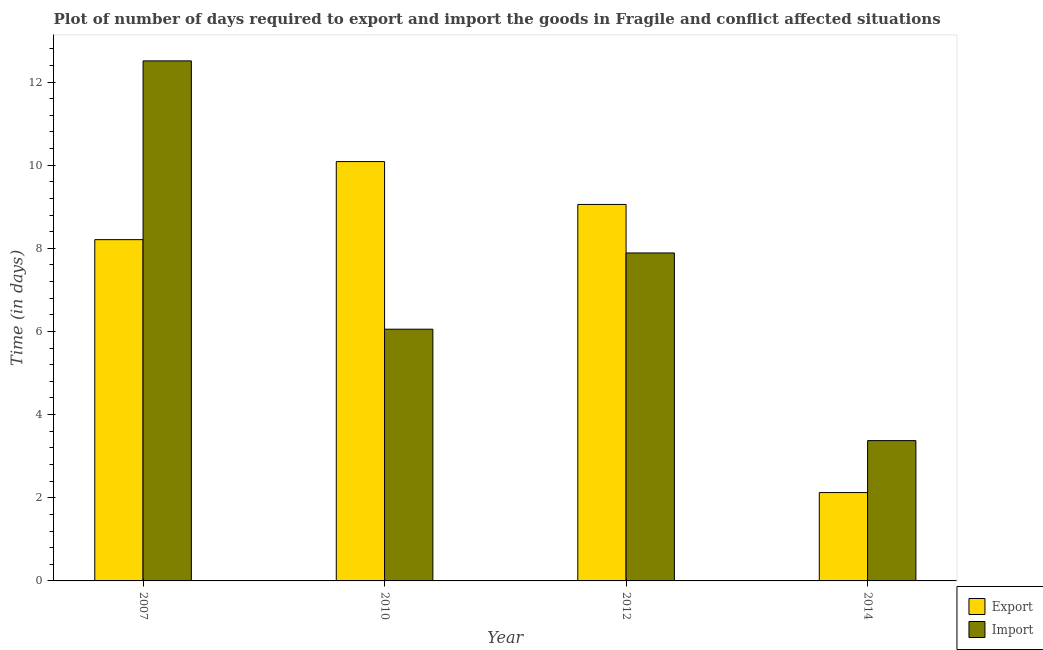Are the number of bars per tick equal to the number of legend labels?
Offer a very short reply. Yes. Are the number of bars on each tick of the X-axis equal?
Keep it short and to the point. Yes. How many bars are there on the 1st tick from the left?
Ensure brevity in your answer.  2. In how many cases, is the number of bars for a given year not equal to the number of legend labels?
Your response must be concise. 0. What is the time required to import in 2010?
Your answer should be very brief. 6.05. Across all years, what is the maximum time required to import?
Your answer should be compact. 12.51. Across all years, what is the minimum time required to import?
Your answer should be very brief. 3.38. What is the total time required to export in the graph?
Give a very brief answer. 29.48. What is the difference between the time required to export in 2007 and that in 2014?
Make the answer very short. 6.08. What is the difference between the time required to export in 2012 and the time required to import in 2010?
Ensure brevity in your answer.  -1.03. What is the average time required to import per year?
Make the answer very short. 7.46. In the year 2007, what is the difference between the time required to export and time required to import?
Keep it short and to the point. 0. What is the ratio of the time required to export in 2007 to that in 2014?
Give a very brief answer. 3.86. What is the difference between the highest and the second highest time required to export?
Your answer should be compact. 1.03. What is the difference between the highest and the lowest time required to export?
Your answer should be compact. 7.96. What does the 1st bar from the left in 2012 represents?
Make the answer very short. Export. What does the 2nd bar from the right in 2012 represents?
Your response must be concise. Export. Are all the bars in the graph horizontal?
Keep it short and to the point. No. What is the difference between two consecutive major ticks on the Y-axis?
Keep it short and to the point. 2. Does the graph contain any zero values?
Ensure brevity in your answer.  No. Where does the legend appear in the graph?
Your answer should be very brief. Bottom right. How are the legend labels stacked?
Ensure brevity in your answer.  Vertical. What is the title of the graph?
Your response must be concise. Plot of number of days required to export and import the goods in Fragile and conflict affected situations. What is the label or title of the Y-axis?
Provide a short and direct response. Time (in days). What is the Time (in days) of Export in 2007?
Make the answer very short. 8.21. What is the Time (in days) of Import in 2007?
Provide a succinct answer. 12.51. What is the Time (in days) of Export in 2010?
Your answer should be very brief. 10.09. What is the Time (in days) of Import in 2010?
Your answer should be compact. 6.05. What is the Time (in days) in Export in 2012?
Offer a terse response. 9.06. What is the Time (in days) in Import in 2012?
Your response must be concise. 7.89. What is the Time (in days) in Export in 2014?
Ensure brevity in your answer.  2.12. What is the Time (in days) of Import in 2014?
Offer a terse response. 3.38. Across all years, what is the maximum Time (in days) of Export?
Your response must be concise. 10.09. Across all years, what is the maximum Time (in days) in Import?
Provide a short and direct response. 12.51. Across all years, what is the minimum Time (in days) of Export?
Your answer should be very brief. 2.12. Across all years, what is the minimum Time (in days) of Import?
Your response must be concise. 3.38. What is the total Time (in days) in Export in the graph?
Offer a very short reply. 29.48. What is the total Time (in days) of Import in the graph?
Your response must be concise. 29.83. What is the difference between the Time (in days) in Export in 2007 and that in 2010?
Your response must be concise. -1.88. What is the difference between the Time (in days) of Import in 2007 and that in 2010?
Provide a succinct answer. 6.45. What is the difference between the Time (in days) of Export in 2007 and that in 2012?
Offer a very short reply. -0.85. What is the difference between the Time (in days) in Import in 2007 and that in 2012?
Your response must be concise. 4.62. What is the difference between the Time (in days) in Export in 2007 and that in 2014?
Give a very brief answer. 6.08. What is the difference between the Time (in days) of Import in 2007 and that in 2014?
Keep it short and to the point. 9.13. What is the difference between the Time (in days) of Export in 2010 and that in 2012?
Your answer should be compact. 1.03. What is the difference between the Time (in days) in Import in 2010 and that in 2012?
Make the answer very short. -1.83. What is the difference between the Time (in days) of Export in 2010 and that in 2014?
Your answer should be very brief. 7.96. What is the difference between the Time (in days) in Import in 2010 and that in 2014?
Keep it short and to the point. 2.68. What is the difference between the Time (in days) in Export in 2012 and that in 2014?
Ensure brevity in your answer.  6.93. What is the difference between the Time (in days) in Import in 2012 and that in 2014?
Ensure brevity in your answer.  4.51. What is the difference between the Time (in days) in Export in 2007 and the Time (in days) in Import in 2010?
Your response must be concise. 2.15. What is the difference between the Time (in days) in Export in 2007 and the Time (in days) in Import in 2012?
Give a very brief answer. 0.32. What is the difference between the Time (in days) of Export in 2007 and the Time (in days) of Import in 2014?
Provide a short and direct response. 4.83. What is the difference between the Time (in days) of Export in 2010 and the Time (in days) of Import in 2012?
Your response must be concise. 2.2. What is the difference between the Time (in days) of Export in 2010 and the Time (in days) of Import in 2014?
Your response must be concise. 6.71. What is the difference between the Time (in days) of Export in 2012 and the Time (in days) of Import in 2014?
Give a very brief answer. 5.68. What is the average Time (in days) of Export per year?
Your answer should be compact. 7.37. What is the average Time (in days) of Import per year?
Ensure brevity in your answer.  7.46. In the year 2010, what is the difference between the Time (in days) in Export and Time (in days) in Import?
Your answer should be compact. 4.03. In the year 2012, what is the difference between the Time (in days) in Export and Time (in days) in Import?
Offer a terse response. 1.17. In the year 2014, what is the difference between the Time (in days) of Export and Time (in days) of Import?
Make the answer very short. -1.25. What is the ratio of the Time (in days) in Export in 2007 to that in 2010?
Offer a very short reply. 0.81. What is the ratio of the Time (in days) of Import in 2007 to that in 2010?
Your response must be concise. 2.07. What is the ratio of the Time (in days) of Export in 2007 to that in 2012?
Make the answer very short. 0.91. What is the ratio of the Time (in days) of Import in 2007 to that in 2012?
Your answer should be very brief. 1.59. What is the ratio of the Time (in days) of Export in 2007 to that in 2014?
Your answer should be compact. 3.86. What is the ratio of the Time (in days) of Import in 2007 to that in 2014?
Your response must be concise. 3.71. What is the ratio of the Time (in days) in Export in 2010 to that in 2012?
Make the answer very short. 1.11. What is the ratio of the Time (in days) in Import in 2010 to that in 2012?
Provide a short and direct response. 0.77. What is the ratio of the Time (in days) of Export in 2010 to that in 2014?
Your answer should be compact. 4.75. What is the ratio of the Time (in days) of Import in 2010 to that in 2014?
Provide a short and direct response. 1.79. What is the ratio of the Time (in days) of Export in 2012 to that in 2014?
Provide a succinct answer. 4.26. What is the ratio of the Time (in days) of Import in 2012 to that in 2014?
Offer a very short reply. 2.34. What is the difference between the highest and the second highest Time (in days) in Export?
Your response must be concise. 1.03. What is the difference between the highest and the second highest Time (in days) in Import?
Ensure brevity in your answer.  4.62. What is the difference between the highest and the lowest Time (in days) in Export?
Provide a succinct answer. 7.96. What is the difference between the highest and the lowest Time (in days) of Import?
Provide a succinct answer. 9.13. 